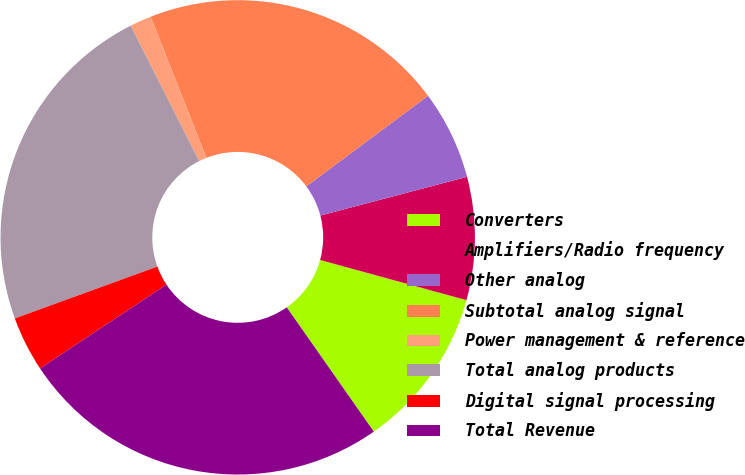<chart> <loc_0><loc_0><loc_500><loc_500><pie_chart><fcel>Converters<fcel>Amplifiers/Radio frequency<fcel>Other analog<fcel>Subtotal analog signal<fcel>Power management & reference<fcel>Total analog products<fcel>Digital signal processing<fcel>Total Revenue<nl><fcel>11.01%<fcel>8.37%<fcel>6.07%<fcel>20.8%<fcel>1.47%<fcel>23.1%<fcel>3.77%<fcel>25.4%<nl></chart> 